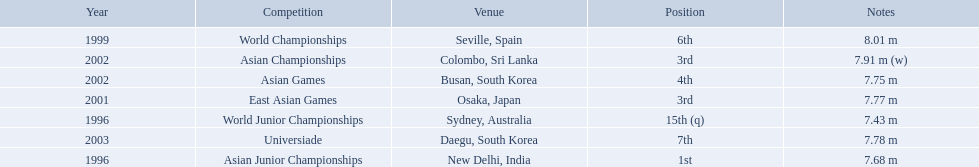Which competition did huang le achieve 3rd place? East Asian Games. Which competition did he achieve 4th place? Asian Games. When did he achieve 1st place? Asian Junior Championships. 